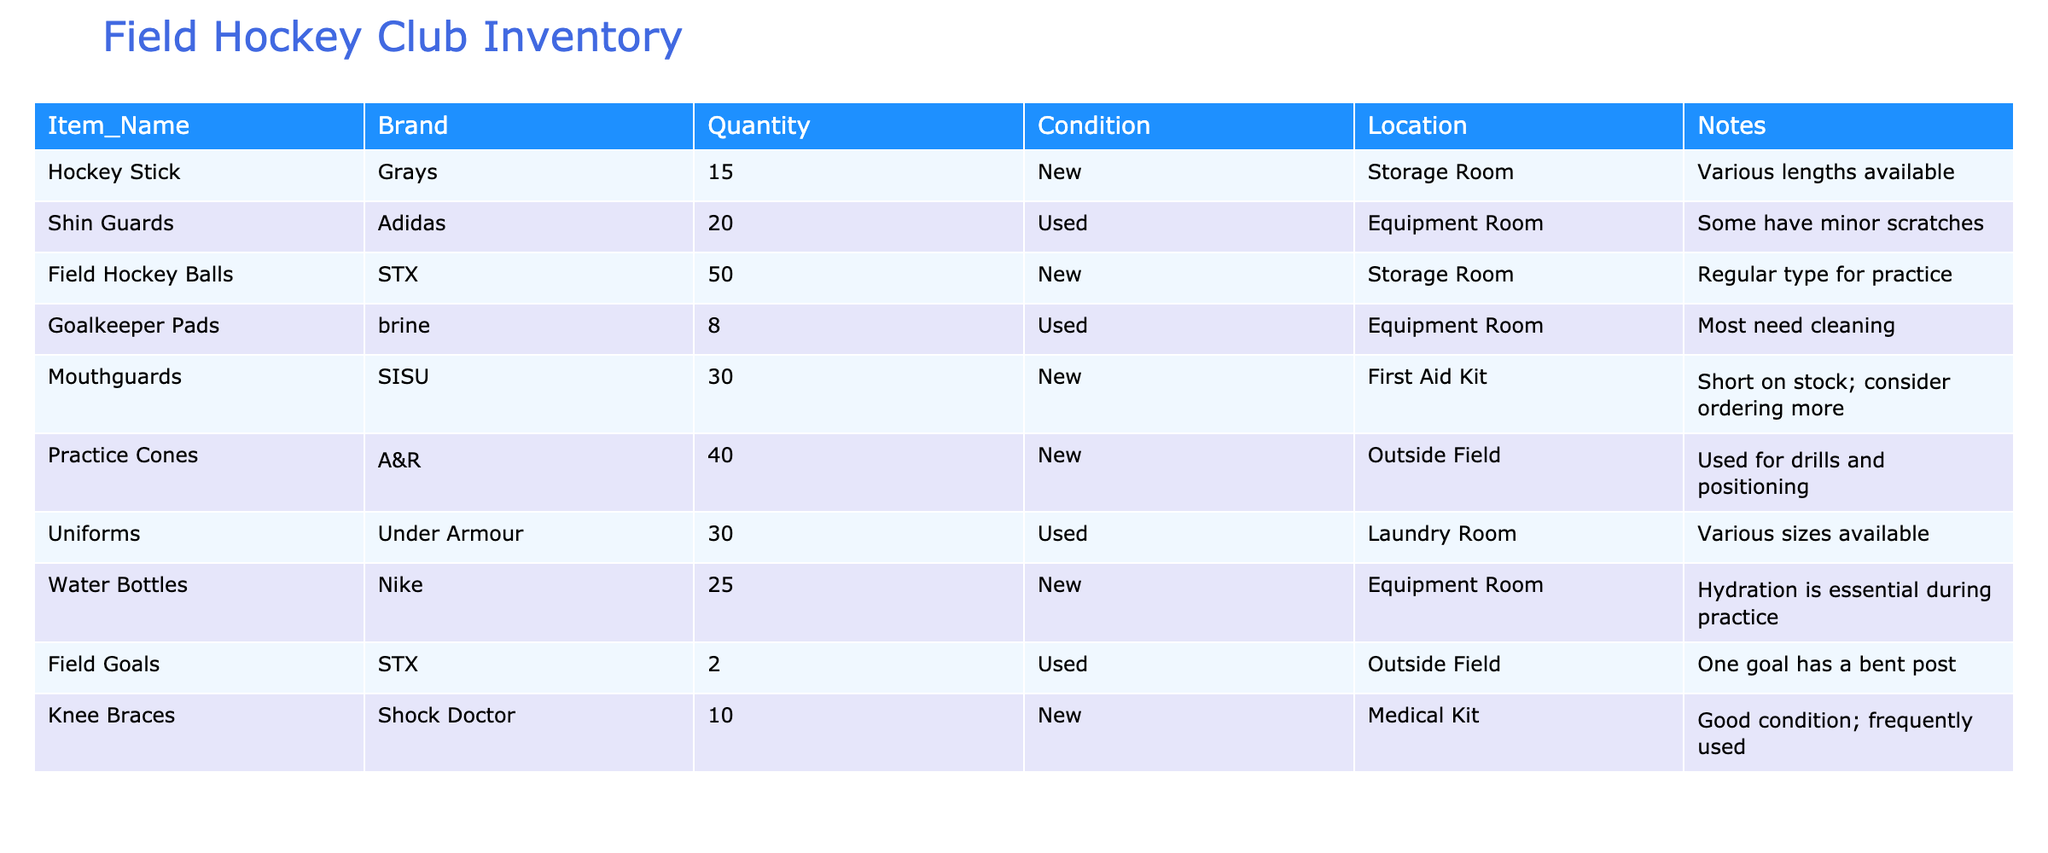What is the total quantity of Shin Guards available? The table shows that there are 20 Shin Guards listed in the Quantity column.
Answer: 20 How many items in total does the inventory list? By adding up the quantities of all items: 15 (Hockey Sticks) + 20 (Shin Guards) + 50 (Field Hockey Balls) + 8 (Goalkeeper Pads) + 30 (Mouthguards) + 40 (Practice Cones) + 30 (Uniforms) + 25 (Water Bottles) + 2 (Field Goals) + 10 (Knee Braces) = 230.
Answer: 230 Are all Mouthguards listed as new? The table specifies that there are 30 Mouthguards and they are all marked as New in the Condition column, confirming they have not been used.
Answer: Yes How many more Water Bottles are there compared to Goalkeeper Pads? There are 25 Water Bottles and 8 Goalkeeper Pads. To find the difference, subtract: 25 - 8 = 17. There are 17 more Water Bottles than Goalkeeper Pads.
Answer: 17 What is the percentage of new items in the inventory? There are 6 New items: Hockey Sticks (15), Field Hockey Balls (50), Mouthguards (30), Practice Cones (40), Water Bottles (25), and Knee Braces (10). The total number of items is 230. The percentage is calculated as (6/10) * 100 = 60%.
Answer: 60% How many items are in used condition? By analyzing the table, the used items include: Shin Guards (20), Goalkeeper Pads (8), and Uniforms (30). Adding these gives: 20 + 8 + 30 = 58 used items.
Answer: 58 Is there a need to order more Mouthguards? The notes indicate that the stock of Mouthguards is short, implying that it's advisable to order more.
Answer: Yes How many maximum Field Goals are available, considering one has a bent post? The table shows 2 Field Goals are available, but one is noted to have a bent post, indicating only one is in optimal condition. Therefore, the maximum available that is in good condition is 1.
Answer: 1 What is the ratio of new items to used items in the inventory? There are 6 new items and 4 used items. The ratio is calculated as 6 to 4, which can also be simplified to 3 to 2.
Answer: 3:2 